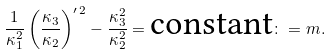<formula> <loc_0><loc_0><loc_500><loc_500>\frac { 1 } { \kappa _ { 1 } ^ { 2 } } \left ( \frac { \kappa _ { 3 } } { \kappa _ { 2 } } \right ) ^ { \prime \, 2 } - \frac { \kappa _ { 3 } ^ { 2 } } { \kappa _ { 2 } ^ { 2 } } = \text {constant} \colon = m .</formula> 